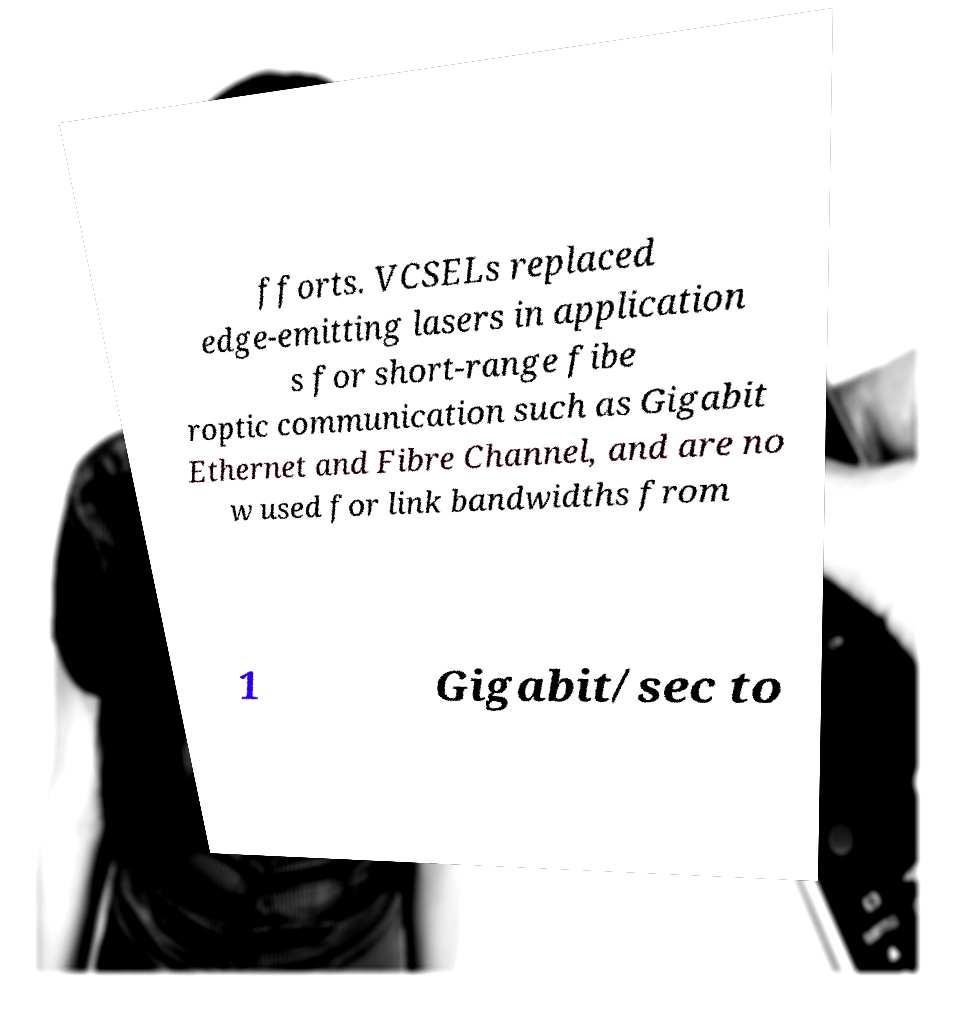I need the written content from this picture converted into text. Can you do that? fforts. VCSELs replaced edge-emitting lasers in application s for short-range fibe roptic communication such as Gigabit Ethernet and Fibre Channel, and are no w used for link bandwidths from 1 Gigabit/sec to 